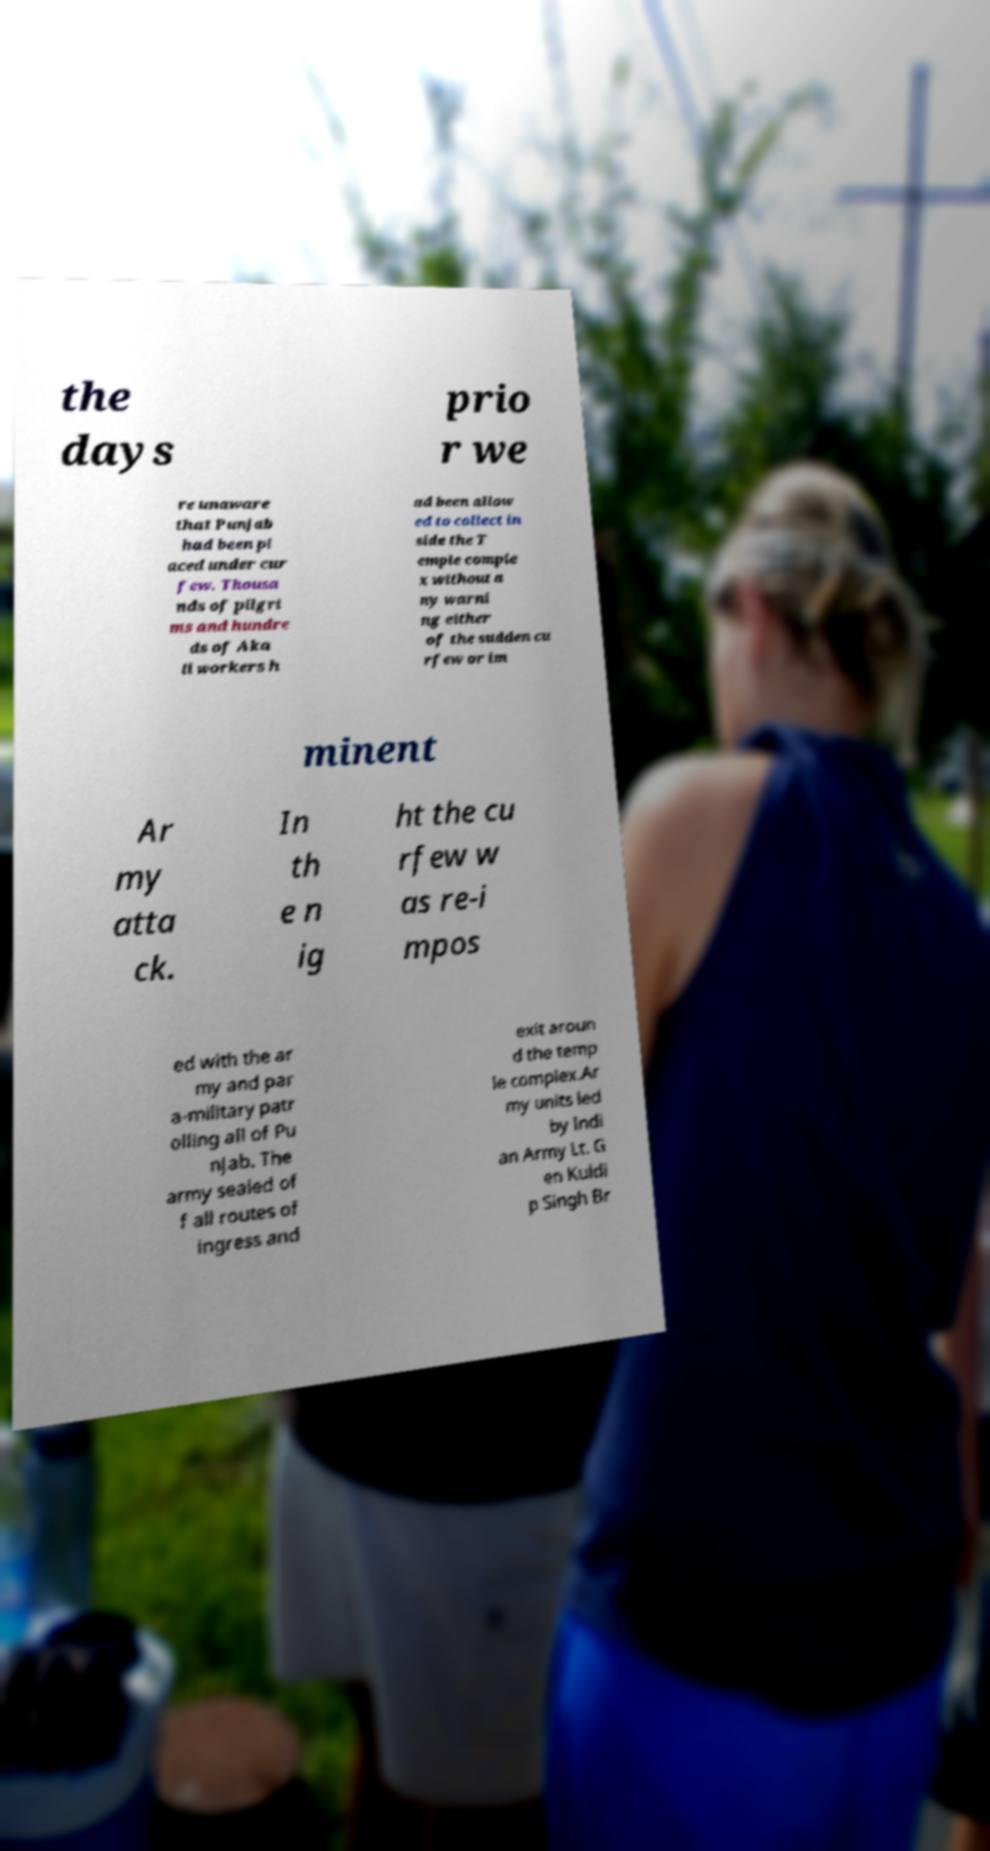Please identify and transcribe the text found in this image. the days prio r we re unaware that Punjab had been pl aced under cur few. Thousa nds of pilgri ms and hundre ds of Aka li workers h ad been allow ed to collect in side the T emple comple x without a ny warni ng either of the sudden cu rfew or im minent Ar my atta ck. In th e n ig ht the cu rfew w as re-i mpos ed with the ar my and par a-military patr olling all of Pu njab. The army sealed of f all routes of ingress and exit aroun d the temp le complex.Ar my units led by Indi an Army Lt. G en Kuldi p Singh Br 